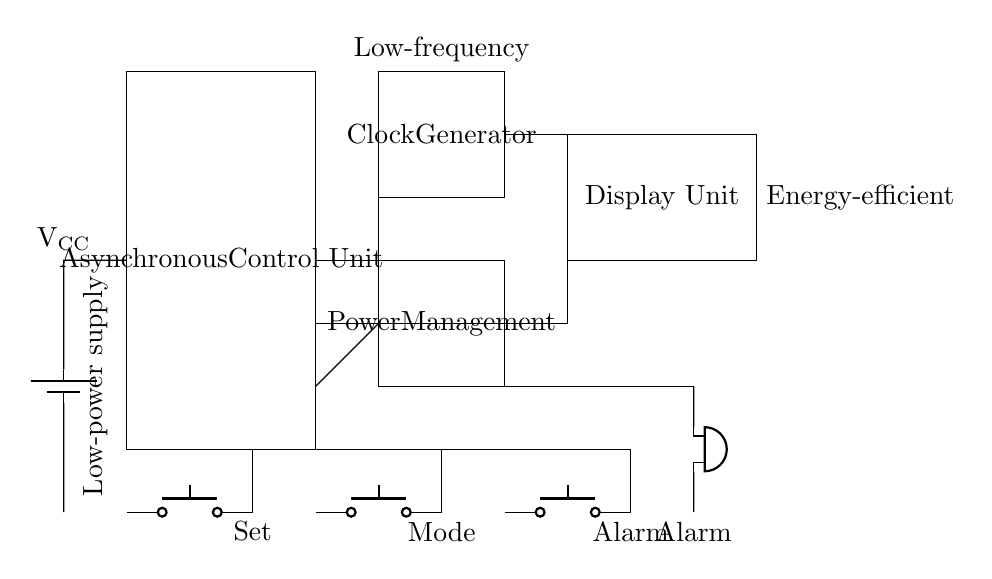What is the main component responsible for timekeeping in this circuit? The main component responsible for timekeeping is the Clock Generator, as it provides the necessary timing signals for the asynchronous control unit to operate effectively.
Answer: Clock Generator What type of output does this circuit provide for alarms? The output is an audible alert produced by the buzzer when the alarm time is reached, making it clear and effective in signaling the user.
Answer: Buzzer How many push buttons are present in this circuit? There are three push buttons in the circuit, which are labeled as Set, Mode, and Alarm, allowing user interaction with the device.
Answer: Three What is the purpose of the Power Management unit? The Power Management unit regulates the power supply to the entire circuit, ensuring energy efficiency and managing the operation of various components to prolong battery life.
Answer: Energy efficiency How does the Asynchronous Control Unit benefit this design? The Asynchronous Control Unit allows for independent operation of components based on the user inputs, reducing power consumption by only activating those components when necessary rather than maintaining a constant operation.
Answer: Reducing power consumption 